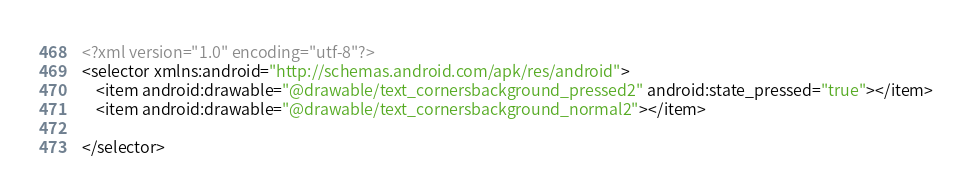Convert code to text. <code><loc_0><loc_0><loc_500><loc_500><_XML_><?xml version="1.0" encoding="utf-8"?>
<selector xmlns:android="http://schemas.android.com/apk/res/android">
    <item android:drawable="@drawable/text_cornersbackground_pressed2" android:state_pressed="true"></item>
    <item android:drawable="@drawable/text_cornersbackground_normal2"></item>
    
</selector></code> 